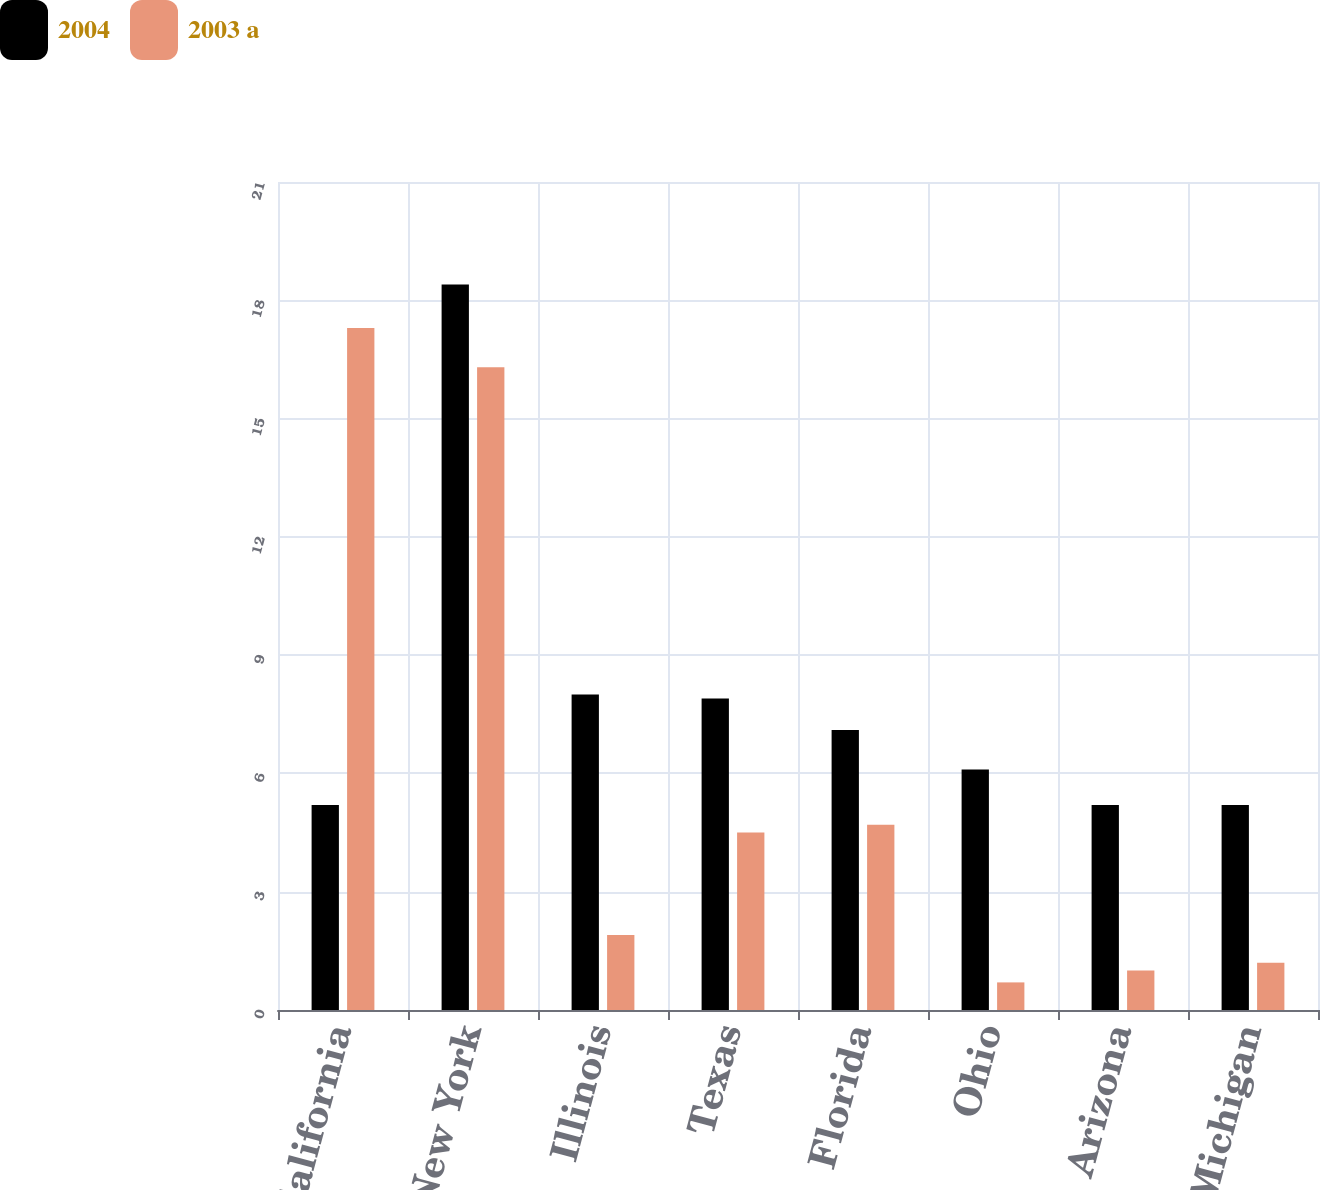Convert chart. <chart><loc_0><loc_0><loc_500><loc_500><stacked_bar_chart><ecel><fcel>California<fcel>New York<fcel>Illinois<fcel>Texas<fcel>Florida<fcel>Ohio<fcel>Arizona<fcel>Michigan<nl><fcel>2004<fcel>5.2<fcel>18.4<fcel>8<fcel>7.9<fcel>7.1<fcel>6.1<fcel>5.2<fcel>5.2<nl><fcel>2003 a<fcel>17.3<fcel>16.3<fcel>1.9<fcel>4.5<fcel>4.7<fcel>0.7<fcel>1<fcel>1.2<nl></chart> 